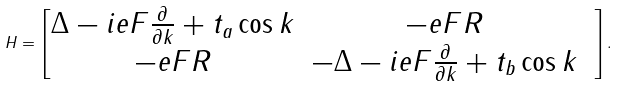Convert formula to latex. <formula><loc_0><loc_0><loc_500><loc_500>H = \begin{bmatrix} \Delta - i e F \frac { \partial } { \partial k } + t _ { a } \cos k & - e F R \\ - e F R & - \Delta - i e F \frac { \partial } { \partial k } + t _ { b } \cos k & \end{bmatrix} .</formula> 